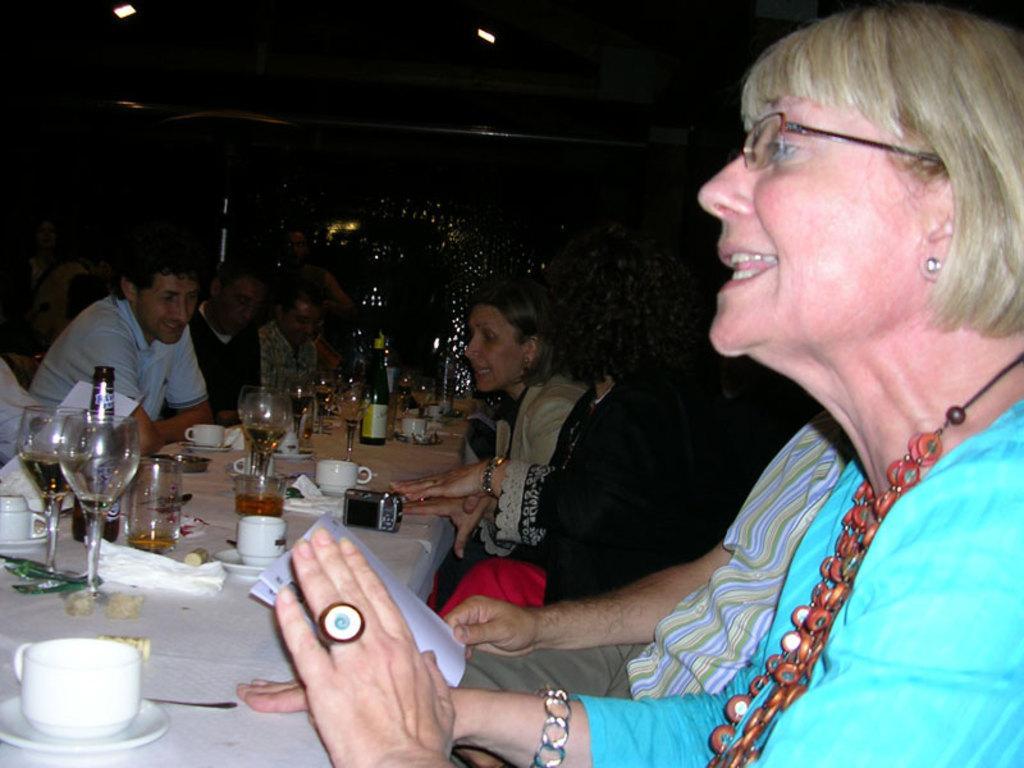Could you give a brief overview of what you see in this image? In this image there are people sitting on the chairs. In front of them there is a table. On top of it there are cups, glasses, tissues, bottles and there is a camera. Behind them there are lights. 